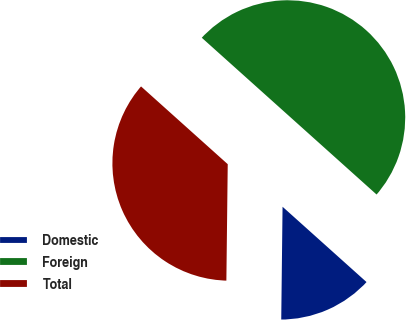Convert chart to OTSL. <chart><loc_0><loc_0><loc_500><loc_500><pie_chart><fcel>Domestic<fcel>Foreign<fcel>Total<nl><fcel>13.55%<fcel>50.0%<fcel>36.45%<nl></chart> 